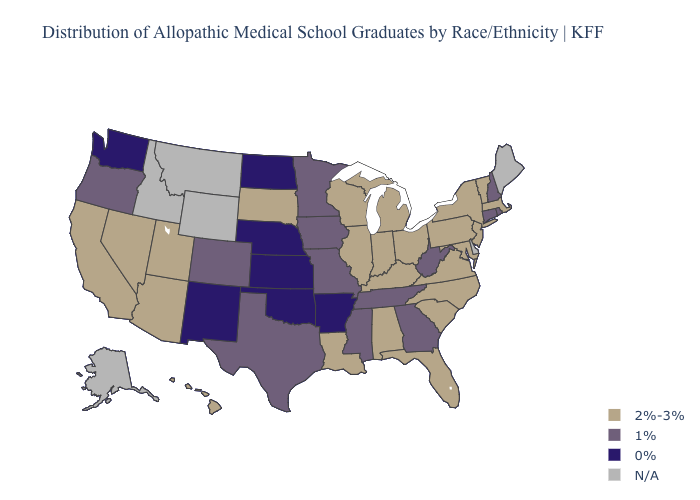What is the value of Wyoming?
Give a very brief answer. N/A. Does Michigan have the highest value in the MidWest?
Be succinct. Yes. What is the lowest value in states that border Nebraska?
Give a very brief answer. 0%. Does Ohio have the highest value in the MidWest?
Be succinct. Yes. Does New Hampshire have the lowest value in the Northeast?
Write a very short answer. Yes. Does Minnesota have the lowest value in the MidWest?
Answer briefly. No. Which states have the highest value in the USA?
Give a very brief answer. Alabama, Arizona, California, Florida, Hawaii, Illinois, Indiana, Kentucky, Louisiana, Maryland, Massachusetts, Michigan, Nevada, New Jersey, New York, North Carolina, Ohio, Pennsylvania, South Carolina, South Dakota, Utah, Vermont, Virginia, Wisconsin. What is the value of Nebraska?
Short answer required. 0%. What is the value of Hawaii?
Give a very brief answer. 2%-3%. Name the states that have a value in the range 2%-3%?
Keep it brief. Alabama, Arizona, California, Florida, Hawaii, Illinois, Indiana, Kentucky, Louisiana, Maryland, Massachusetts, Michigan, Nevada, New Jersey, New York, North Carolina, Ohio, Pennsylvania, South Carolina, South Dakota, Utah, Vermont, Virginia, Wisconsin. Which states hav the highest value in the Northeast?
Give a very brief answer. Massachusetts, New Jersey, New York, Pennsylvania, Vermont. Name the states that have a value in the range 0%?
Concise answer only. Arkansas, Kansas, Nebraska, New Mexico, North Dakota, Oklahoma, Washington. Name the states that have a value in the range 1%?
Be succinct. Colorado, Connecticut, Georgia, Iowa, Minnesota, Mississippi, Missouri, New Hampshire, Oregon, Rhode Island, Tennessee, Texas, West Virginia. Is the legend a continuous bar?
Write a very short answer. No. 